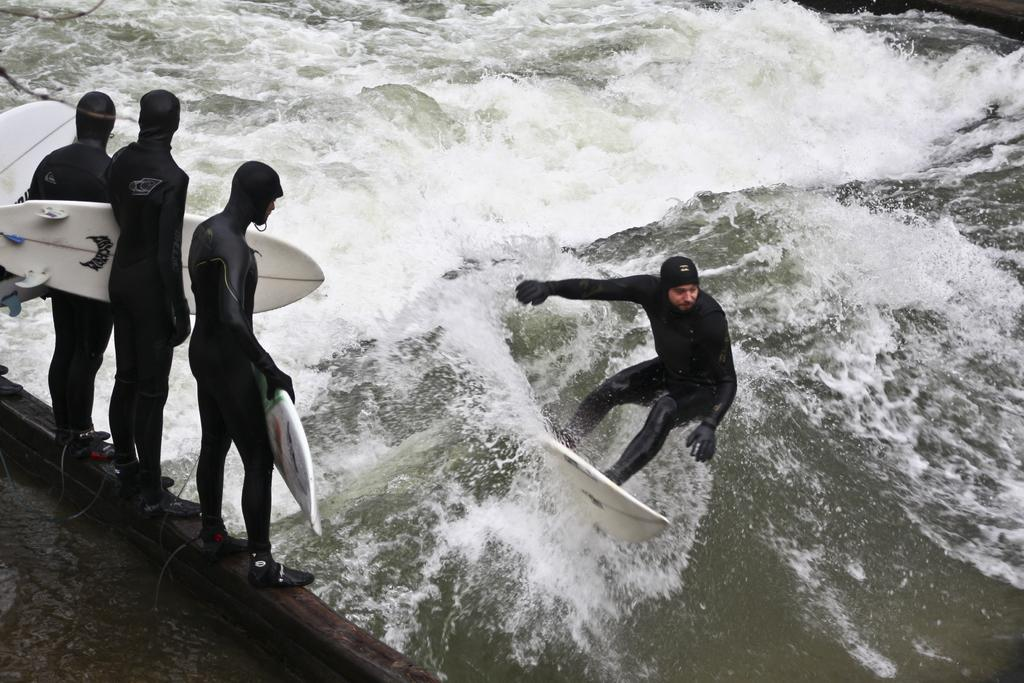What is the person in the water doing in the image? There is a person on a skateboard in the water. Where are the other persons located in the image? The other persons are holding a skateboard on the left side. What type of worm can be seen crawling in the water near the skateboard? There is no worm present in the image; it features a person on a skateboard in the water and persons holding a skateboard on the left side. What type of meat is being prepared by the person on the skateboard? There is no meat or cooking activity present in the image. 